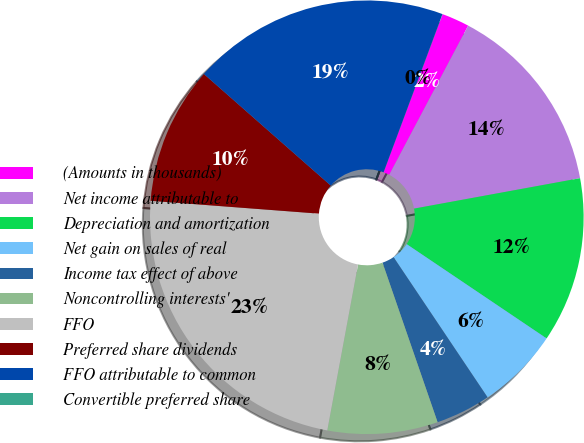Convert chart to OTSL. <chart><loc_0><loc_0><loc_500><loc_500><pie_chart><fcel>(Amounts in thousands)<fcel>Net income attributable to<fcel>Depreciation and amortization<fcel>Net gain on sales of real<fcel>Income tax effect of above<fcel>Noncontrolling interests'<fcel>FFO<fcel>Preferred share dividends<fcel>FFO attributable to common<fcel>Convertible preferred share<nl><fcel>2.06%<fcel>14.37%<fcel>12.32%<fcel>6.16%<fcel>4.11%<fcel>8.21%<fcel>23.29%<fcel>10.27%<fcel>19.19%<fcel>0.01%<nl></chart> 